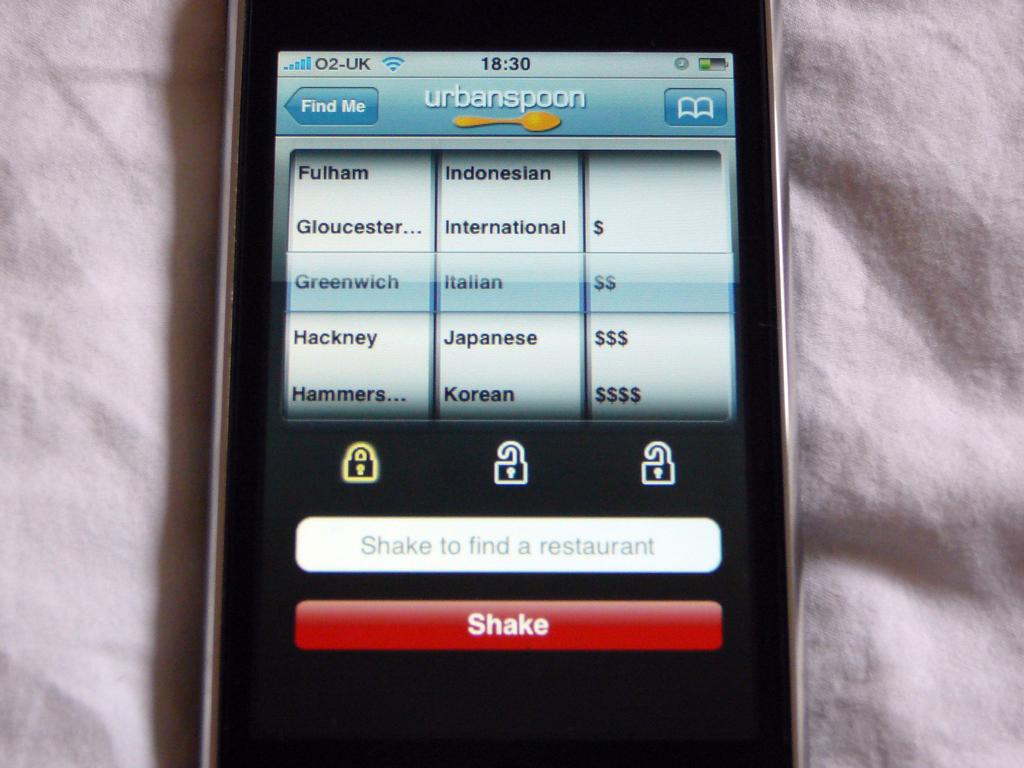Provide a one-sentence caption for the provided image. A cellphone shows the urbanspoon site on its display screen. 